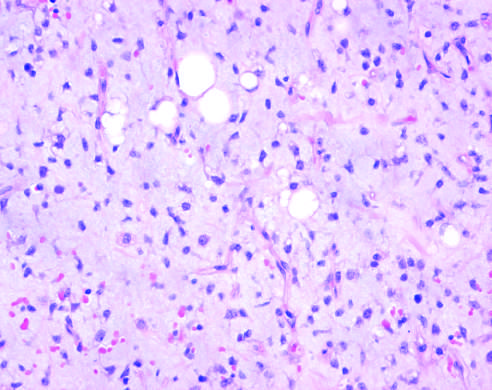re there scattered immature adipocytes and more primitive round-to-stellate cells in myxoid liposarcoma with abundant ground substance and a rich capillary network?
Answer the question using a single word or phrase. Yes 